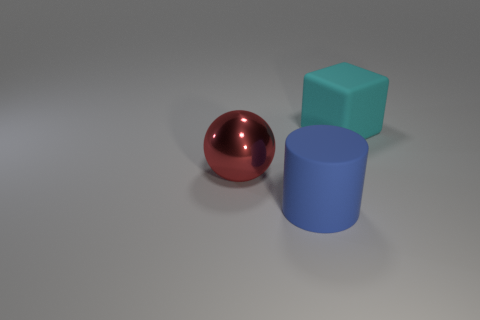Are there any big brown balls that have the same material as the big blue object?
Ensure brevity in your answer.  No. Do the red metal thing and the rubber object to the right of the blue object have the same shape?
Your answer should be compact. No. Are there any large blue things to the left of the cyan thing?
Your answer should be compact. Yes. Do the blue cylinder and the large thing that is on the right side of the large blue thing have the same material?
Offer a very short reply. Yes. How many big shiny objects are there?
Your answer should be very brief. 1. There is a thing on the right side of the blue thing; what size is it?
Your answer should be compact. Large. How many other red metal blocks have the same size as the cube?
Your response must be concise. 0. What is the object that is behind the matte cylinder and on the right side of the red thing made of?
Your answer should be compact. Rubber. There is a blue thing that is the same size as the cyan matte object; what is it made of?
Provide a succinct answer. Rubber. What shape is the matte object in front of the large red metal thing?
Offer a terse response. Cylinder. 